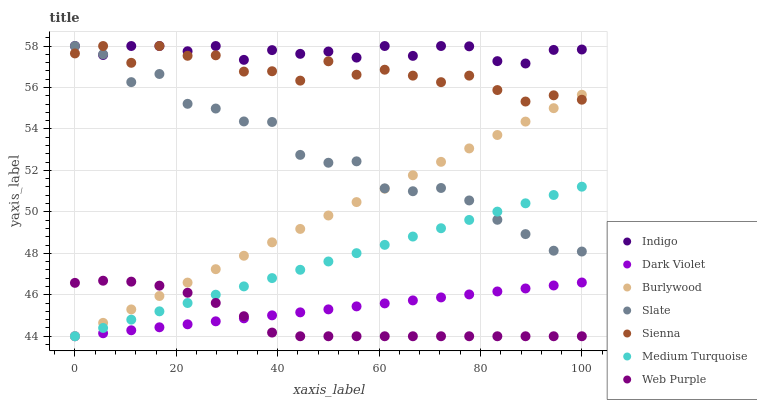Does Web Purple have the minimum area under the curve?
Answer yes or no. Yes. Does Indigo have the maximum area under the curve?
Answer yes or no. Yes. Does Burlywood have the minimum area under the curve?
Answer yes or no. No. Does Burlywood have the maximum area under the curve?
Answer yes or no. No. Is Medium Turquoise the smoothest?
Answer yes or no. Yes. Is Slate the roughest?
Answer yes or no. Yes. Is Burlywood the smoothest?
Answer yes or no. No. Is Burlywood the roughest?
Answer yes or no. No. Does Burlywood have the lowest value?
Answer yes or no. Yes. Does Slate have the lowest value?
Answer yes or no. No. Does Sienna have the highest value?
Answer yes or no. Yes. Does Burlywood have the highest value?
Answer yes or no. No. Is Web Purple less than Sienna?
Answer yes or no. Yes. Is Slate greater than Dark Violet?
Answer yes or no. Yes. Does Dark Violet intersect Medium Turquoise?
Answer yes or no. Yes. Is Dark Violet less than Medium Turquoise?
Answer yes or no. No. Is Dark Violet greater than Medium Turquoise?
Answer yes or no. No. Does Web Purple intersect Sienna?
Answer yes or no. No. 